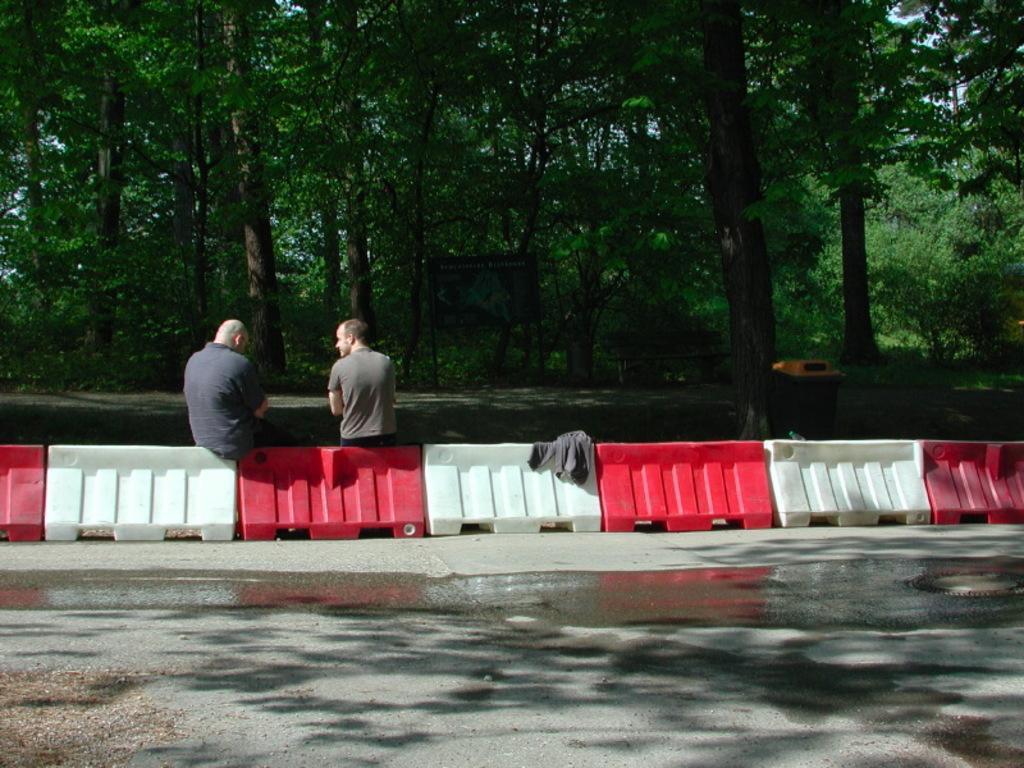Describe this image in one or two sentences. In this picture I can observe two men sitting on the divider. The divider is in red and white color. I can observe a road in the bottom of the picture. In the background there are trees. 